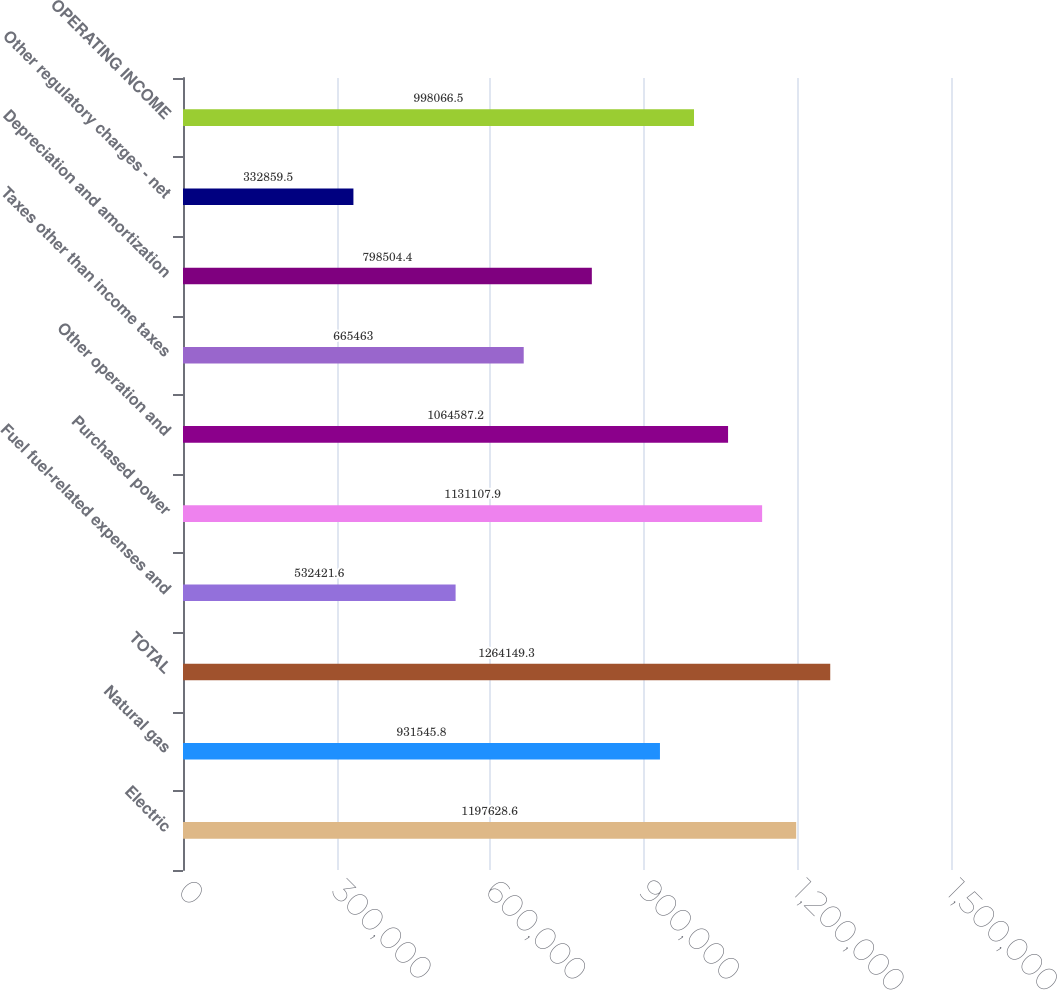<chart> <loc_0><loc_0><loc_500><loc_500><bar_chart><fcel>Electric<fcel>Natural gas<fcel>TOTAL<fcel>Fuel fuel-related expenses and<fcel>Purchased power<fcel>Other operation and<fcel>Taxes other than income taxes<fcel>Depreciation and amortization<fcel>Other regulatory charges - net<fcel>OPERATING INCOME<nl><fcel>1.19763e+06<fcel>931546<fcel>1.26415e+06<fcel>532422<fcel>1.13111e+06<fcel>1.06459e+06<fcel>665463<fcel>798504<fcel>332860<fcel>998066<nl></chart> 